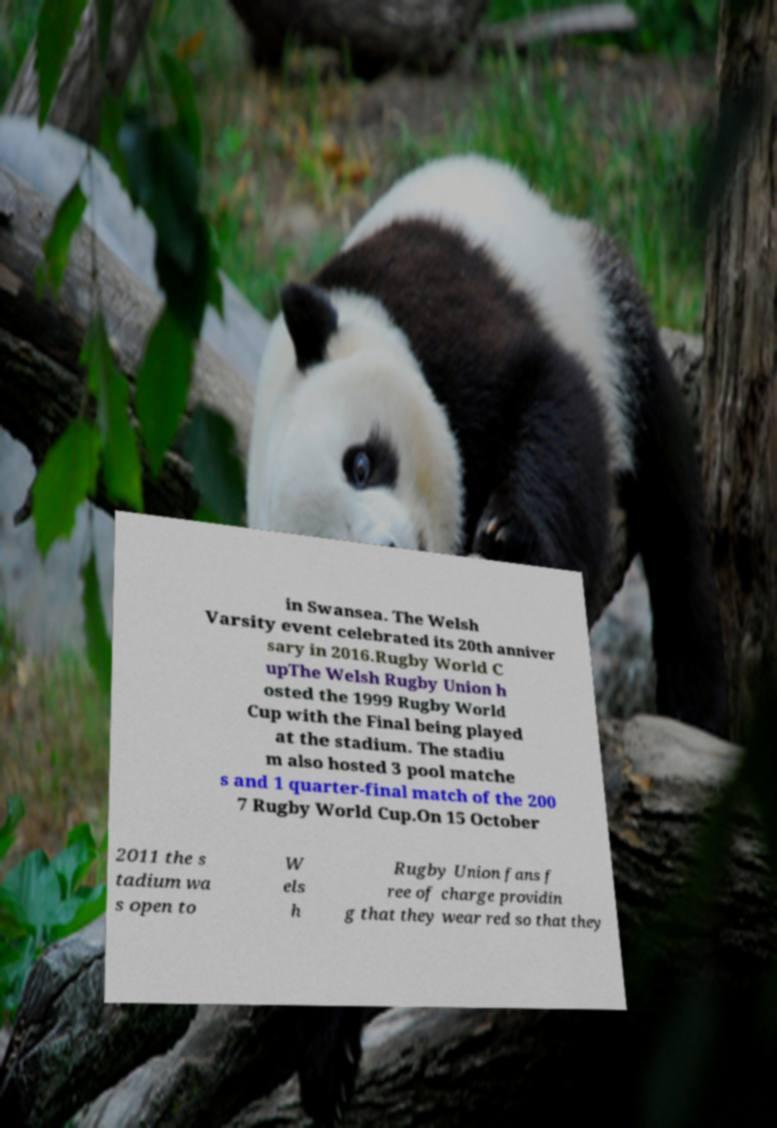I need the written content from this picture converted into text. Can you do that? in Swansea. The Welsh Varsity event celebrated its 20th anniver sary in 2016.Rugby World C upThe Welsh Rugby Union h osted the 1999 Rugby World Cup with the Final being played at the stadium. The stadiu m also hosted 3 pool matche s and 1 quarter-final match of the 200 7 Rugby World Cup.On 15 October 2011 the s tadium wa s open to W els h Rugby Union fans f ree of charge providin g that they wear red so that they 